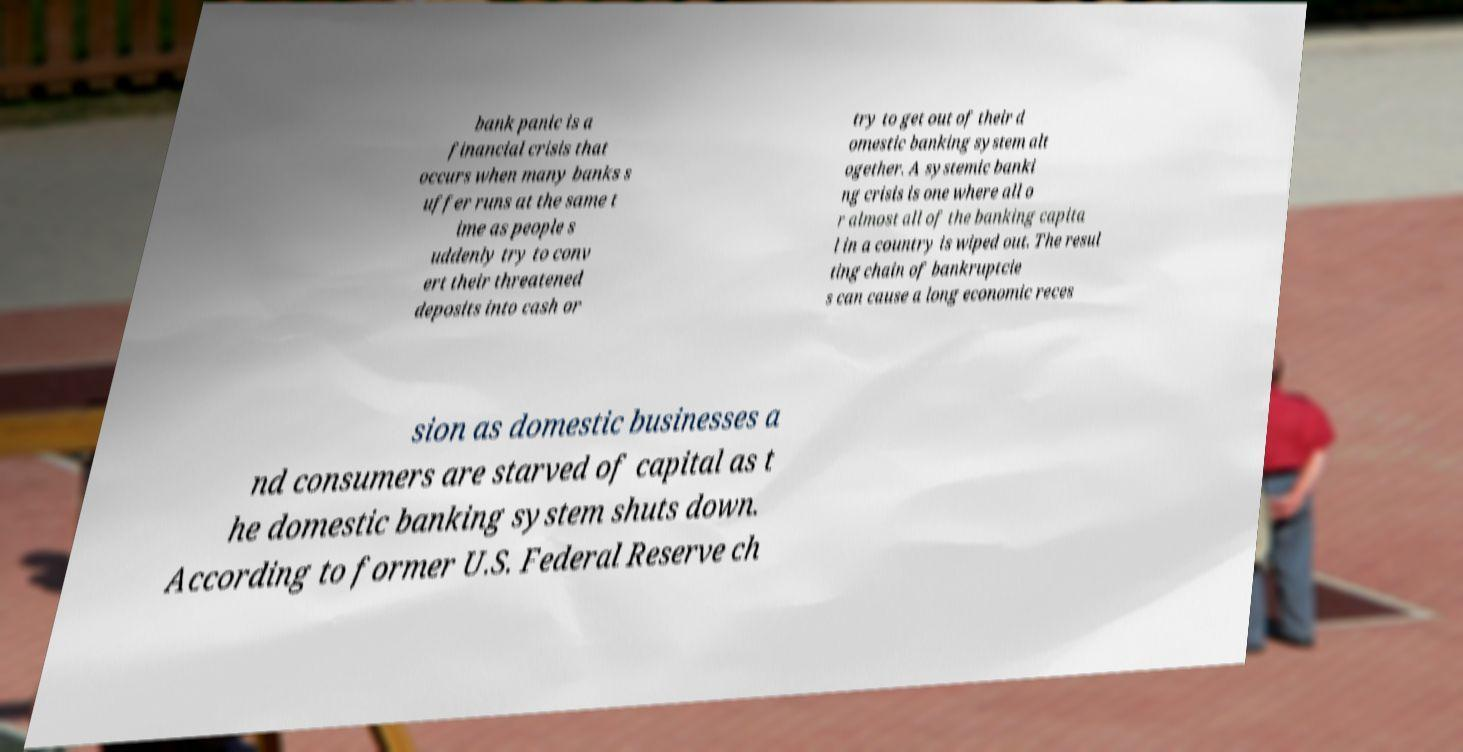For documentation purposes, I need the text within this image transcribed. Could you provide that? bank panic is a financial crisis that occurs when many banks s uffer runs at the same t ime as people s uddenly try to conv ert their threatened deposits into cash or try to get out of their d omestic banking system alt ogether. A systemic banki ng crisis is one where all o r almost all of the banking capita l in a country is wiped out. The resul ting chain of bankruptcie s can cause a long economic reces sion as domestic businesses a nd consumers are starved of capital as t he domestic banking system shuts down. According to former U.S. Federal Reserve ch 